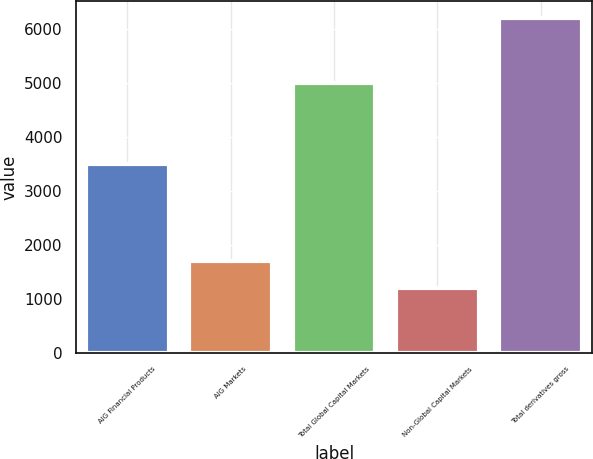Convert chart to OTSL. <chart><loc_0><loc_0><loc_500><loc_500><bar_chart><fcel>AIG Financial Products<fcel>AIG Markets<fcel>Total Global Capital Markets<fcel>Non-Global Capital Markets<fcel>Total derivatives gross<nl><fcel>3506<fcel>1703.2<fcel>5012<fcel>1202<fcel>6214<nl></chart> 